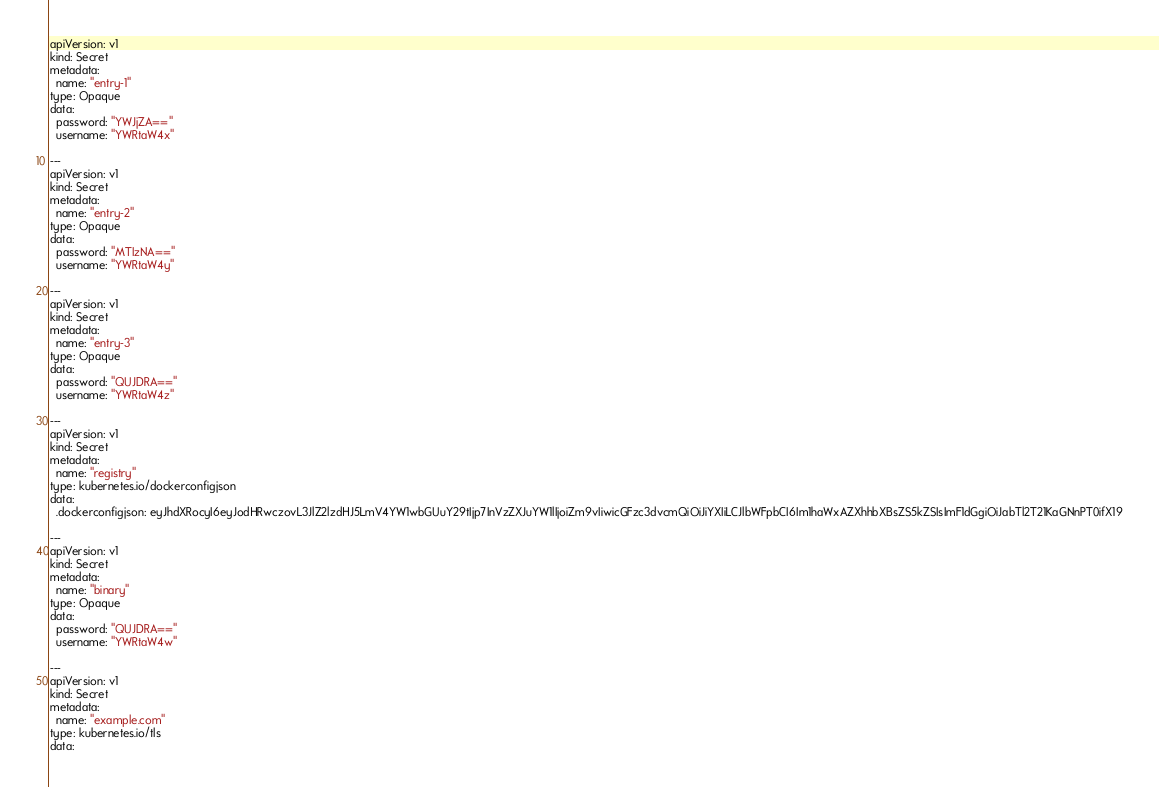Convert code to text. <code><loc_0><loc_0><loc_500><loc_500><_YAML_>apiVersion: v1
kind: Secret
metadata:
  name: "entry-1"
type: Opaque
data:
  password: "YWJjZA=="
  username: "YWRtaW4x"

---
apiVersion: v1
kind: Secret
metadata:
  name: "entry-2"
type: Opaque
data:
  password: "MTIzNA=="
  username: "YWRtaW4y"

---
apiVersion: v1
kind: Secret
metadata:
  name: "entry-3"
type: Opaque
data:
  password: "QUJDRA=="
  username: "YWRtaW4z"

---
apiVersion: v1
kind: Secret
metadata:
  name: "registry"
type: kubernetes.io/dockerconfigjson
data:
  .dockerconfigjson: eyJhdXRocyI6eyJodHRwczovL3JlZ2lzdHJ5LmV4YW1wbGUuY29tIjp7InVzZXJuYW1lIjoiZm9vIiwicGFzc3dvcmQiOiJiYXIiLCJlbWFpbCI6Im1haWxAZXhhbXBsZS5kZSIsImF1dGgiOiJabTl2T21KaGNnPT0ifX19

---
apiVersion: v1
kind: Secret
metadata:
  name: "binary"
type: Opaque
data:
  password: "QUJDRA=="
  username: "YWRtaW4w"

---
apiVersion: v1
kind: Secret
metadata:
  name: "example.com"
type: kubernetes.io/tls
data:</code> 